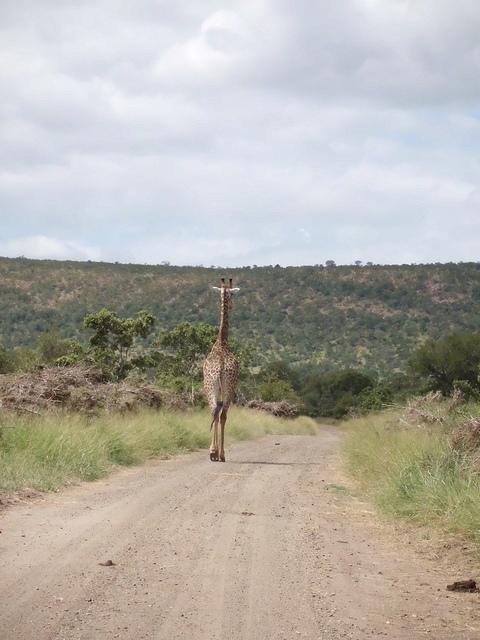Are these animals in the wild?
Give a very brief answer. Yes. Is there a lot of traffic on this road?
Keep it brief. No. Is the giraffe fenced in?
Keep it brief. No. How many vehicles are in view?
Answer briefly. 0. Is this in a parka?
Answer briefly. No. 